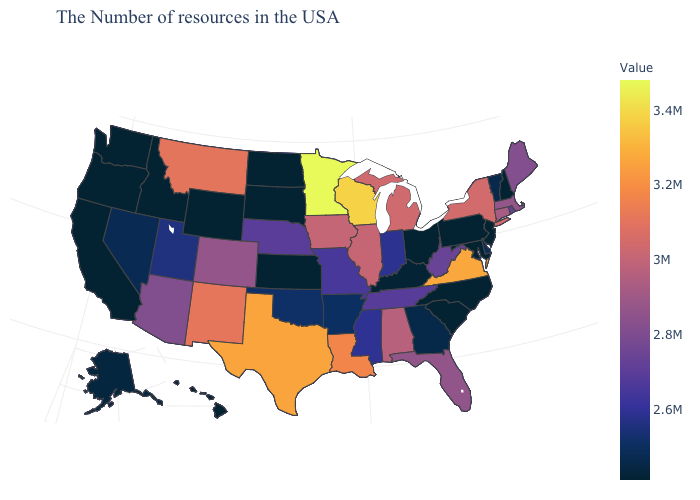Does Hawaii have the lowest value in the West?
Write a very short answer. Yes. Which states hav the highest value in the South?
Quick response, please. Virginia. Among the states that border Minnesota , does Iowa have the lowest value?
Answer briefly. No. 